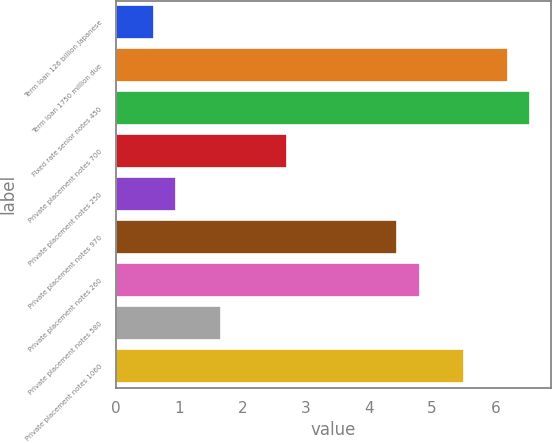Convert chart. <chart><loc_0><loc_0><loc_500><loc_500><bar_chart><fcel>Term loan 126 billion Japanese<fcel>Term loan 1750 million due<fcel>Fixed rate senior notes 450<fcel>Private placement notes 700<fcel>Private placement notes 250<fcel>Private placement notes 970<fcel>Private placement notes 260<fcel>Private placement notes 580<fcel>Private placement notes 1060<nl><fcel>0.6<fcel>6.2<fcel>6.55<fcel>2.7<fcel>0.95<fcel>4.45<fcel>4.8<fcel>1.65<fcel>5.5<nl></chart> 